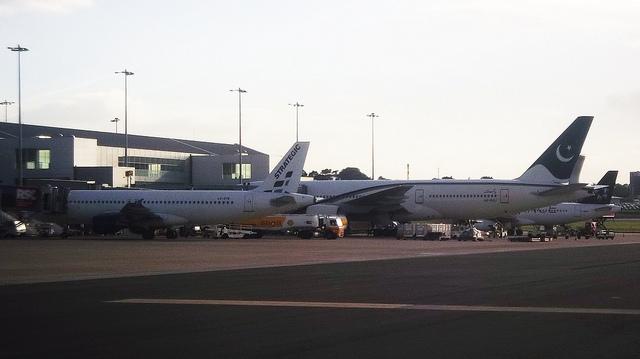Is the plane ready for takeoff?
Short answer required. No. What is the symbol on the tail of the plane?
Give a very brief answer. Moon. How does the pilot get to the cockpit?
Answer briefly. Walk. Is the plane facing away from the camera?
Be succinct. Yes. When departing from this plane, the passengers will go and pick up what?
Short answer required. Luggage. 